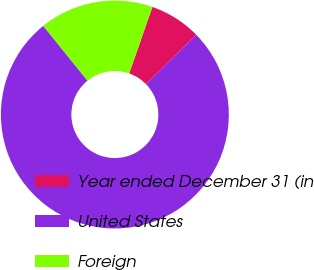<chart> <loc_0><loc_0><loc_500><loc_500><pie_chart><fcel>Year ended December 31 (in<fcel>United States<fcel>Foreign<nl><fcel>7.34%<fcel>76.51%<fcel>16.15%<nl></chart> 